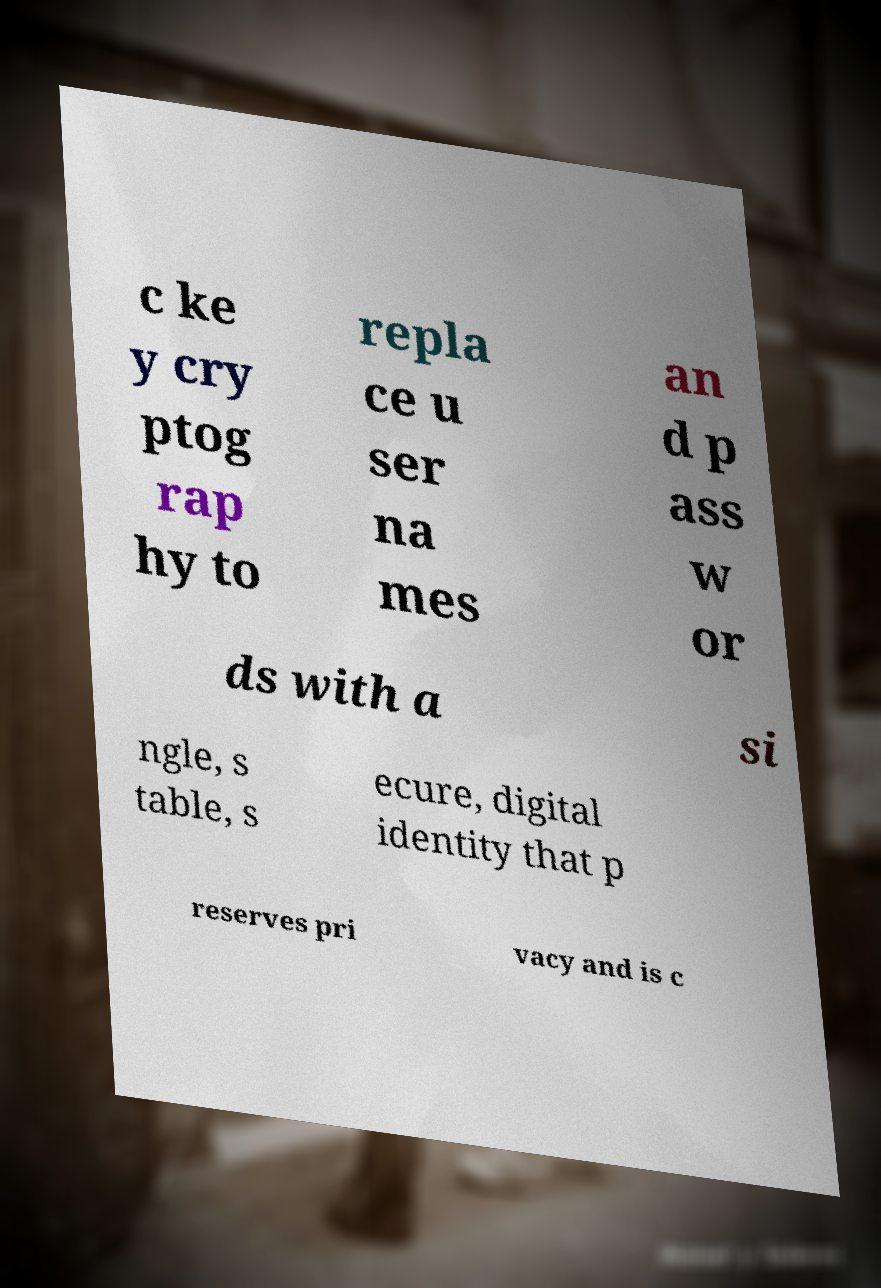Could you assist in decoding the text presented in this image and type it out clearly? c ke y cry ptog rap hy to repla ce u ser na mes an d p ass w or ds with a si ngle, s table, s ecure, digital identity that p reserves pri vacy and is c 